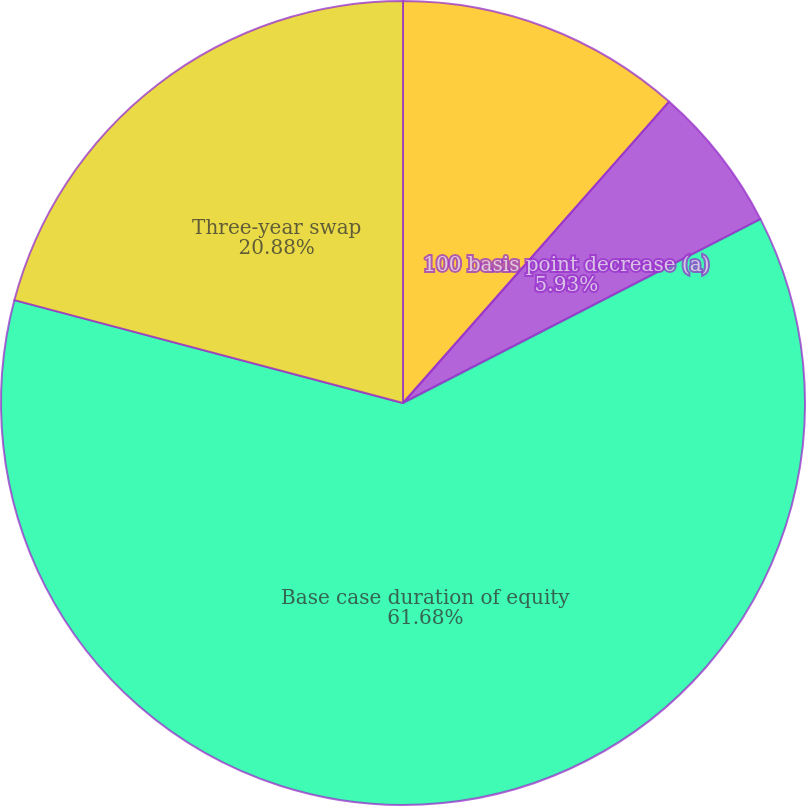<chart> <loc_0><loc_0><loc_500><loc_500><pie_chart><fcel>Effect on net interest income<fcel>100 basis point decrease (a)<fcel>Base case duration of equity<fcel>Three-year swap<nl><fcel>11.51%<fcel>5.93%<fcel>61.68%<fcel>20.88%<nl></chart> 